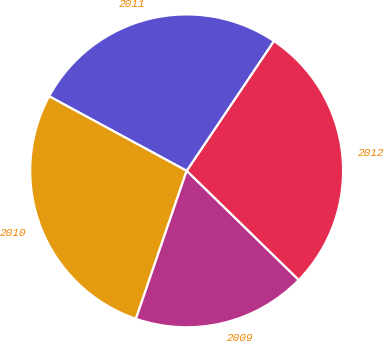<chart> <loc_0><loc_0><loc_500><loc_500><pie_chart><fcel>2012<fcel>2011<fcel>2010<fcel>2009<nl><fcel>27.88%<fcel>26.51%<fcel>27.65%<fcel>17.96%<nl></chart> 